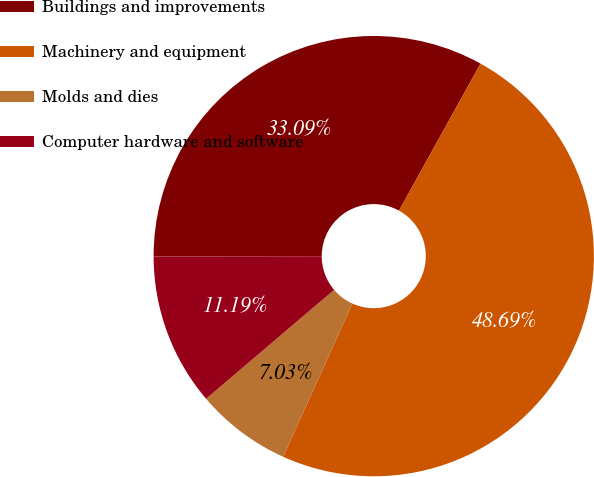Convert chart to OTSL. <chart><loc_0><loc_0><loc_500><loc_500><pie_chart><fcel>Buildings and improvements<fcel>Machinery and equipment<fcel>Molds and dies<fcel>Computer hardware and software<nl><fcel>33.09%<fcel>48.69%<fcel>7.03%<fcel>11.19%<nl></chart> 